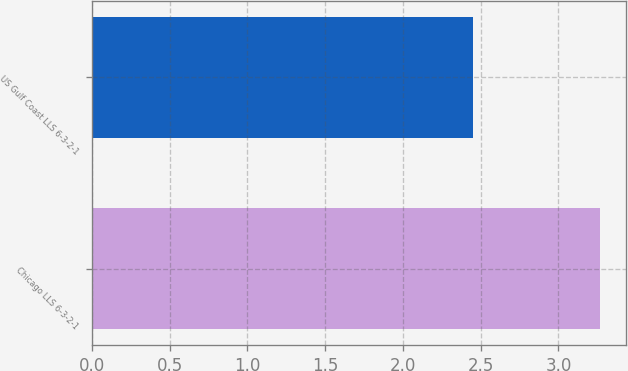Convert chart to OTSL. <chart><loc_0><loc_0><loc_500><loc_500><bar_chart><fcel>Chicago LLS 6-3-2-1<fcel>US Gulf Coast LLS 6-3-2-1<nl><fcel>3.27<fcel>2.45<nl></chart> 